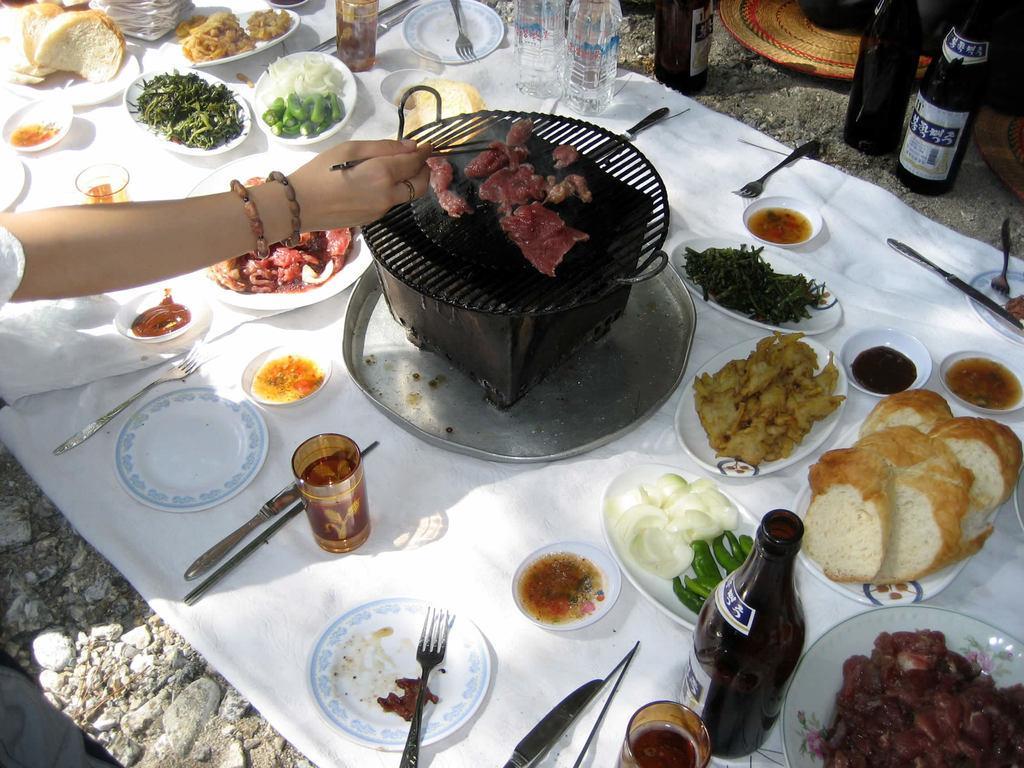Can you describe this image briefly? In this picture we can see food in the plates, beside to the plates we can find few forks, knives, bottles and other things on the cloth, and also we can find a barbeque, and a woman is cooking. 